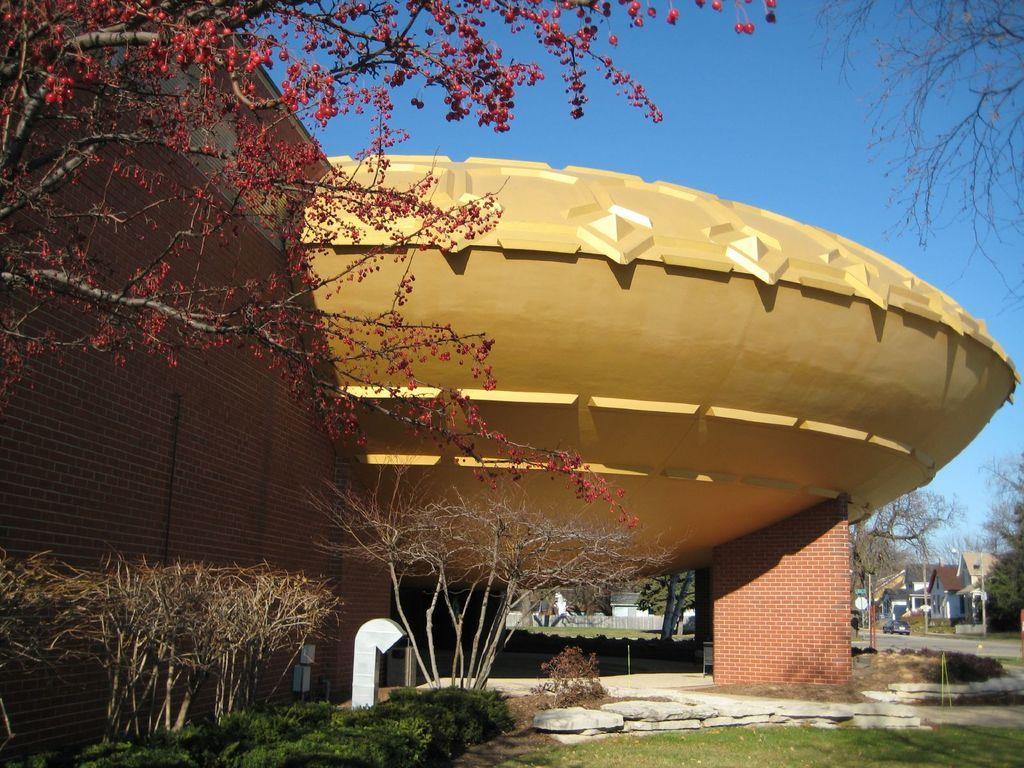What celestial bodies are present in the image? There are planets in the image. What type of structures can be seen in the image? There are buildings in the image. What type of vegetation is present in the image? There are trees in the image. How many beads are hanging from the trees in the image? There are no beads present in the image; it features planets, buildings, and trees. What type of cobweb can be seen in the image? There is no cobweb present in the image. 